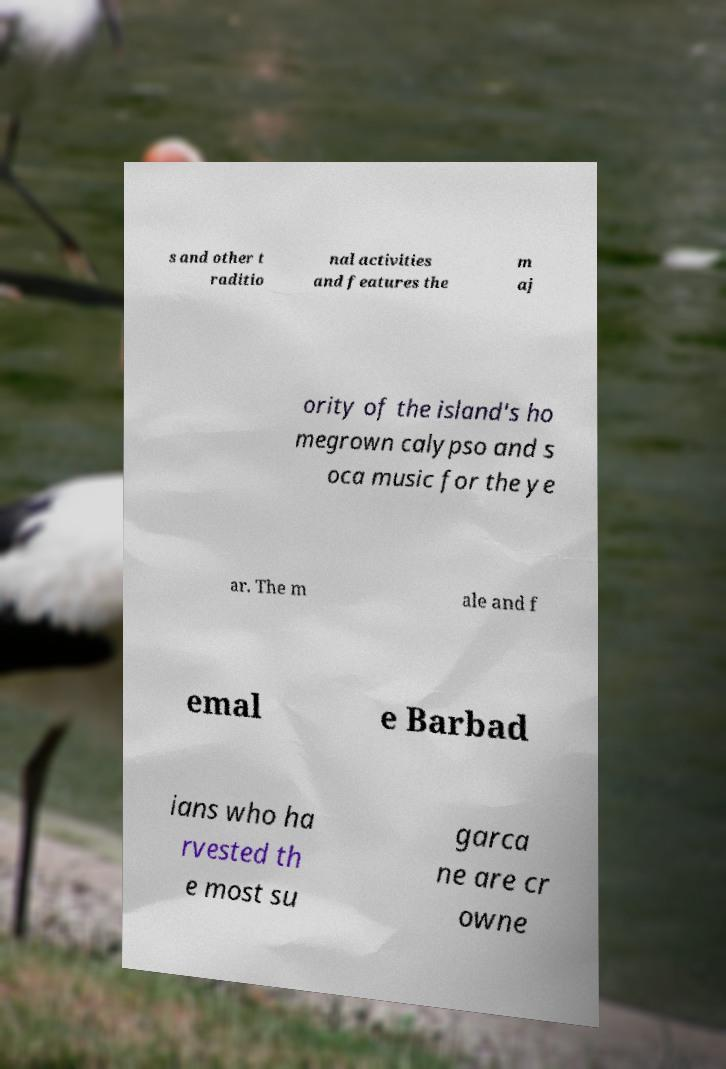Could you extract and type out the text from this image? s and other t raditio nal activities and features the m aj ority of the island's ho megrown calypso and s oca music for the ye ar. The m ale and f emal e Barbad ians who ha rvested th e most su garca ne are cr owne 